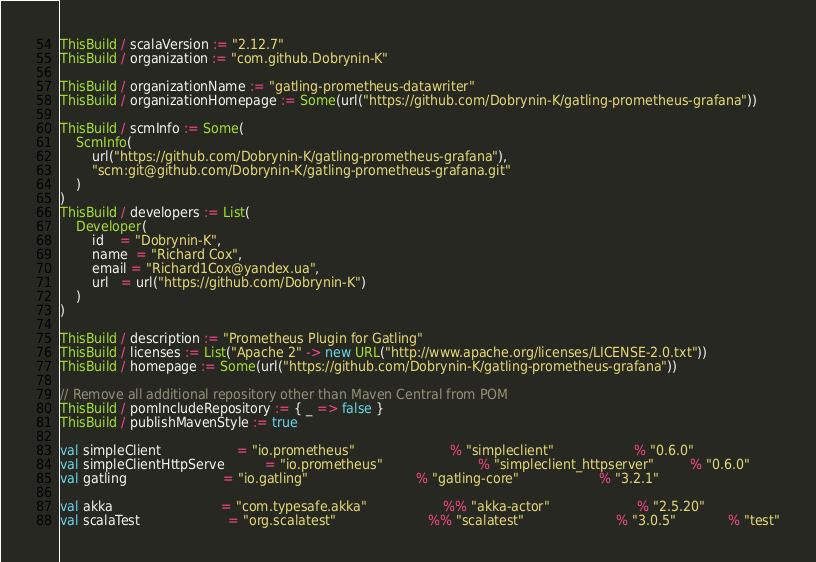<code> <loc_0><loc_0><loc_500><loc_500><_Scala_>

ThisBuild / scalaVersion := "2.12.7"
ThisBuild / organization := "com.github.Dobrynin-K"

ThisBuild / organizationName := "gatling-prometheus-datawriter"
ThisBuild / organizationHomepage := Some(url("https://github.com/Dobrynin-K/gatling-prometheus-grafana"))

ThisBuild / scmInfo := Some(
    ScmInfo(
        url("https://github.com/Dobrynin-K/gatling-prometheus-grafana"),
        "scm:git@github.com/Dobrynin-K/gatling-prometheus-grafana.git"
    )
)
ThisBuild / developers := List(
    Developer(
        id    = "Dobrynin-K",
        name  = "Richard Cox",
        email = "Richard1Cox@yandex.ua",
        url   = url("https://github.com/Dobrynin-K")
    )
)

ThisBuild / description := "Prometheus Plugin for Gatling"
ThisBuild / licenses := List("Apache 2" -> new URL("http://www.apache.org/licenses/LICENSE-2.0.txt"))
ThisBuild / homepage := Some(url("https://github.com/Dobrynin-K/gatling-prometheus-grafana"))

// Remove all additional repository other than Maven Central from POM
ThisBuild / pomIncludeRepository := { _ => false }
ThisBuild / publishMavenStyle := true

val simpleClient                   = "io.prometheus"                        % "simpleclient"                    % "0.6.0"
val simpleClientHttpServe          = "io.prometheus"                        % "simpleclient_httpserver"         % "0.6.0"
val gatling                        = "io.gatling"                           % "gatling-core"                    % "3.2.1"

val akka                           = "com.typesafe.akka"                   %% "akka-actor"                      % "2.5.20"
val scalaTest                      = "org.scalatest"                       %% "scalatest"                       % "3.0.5"             % "test"</code> 